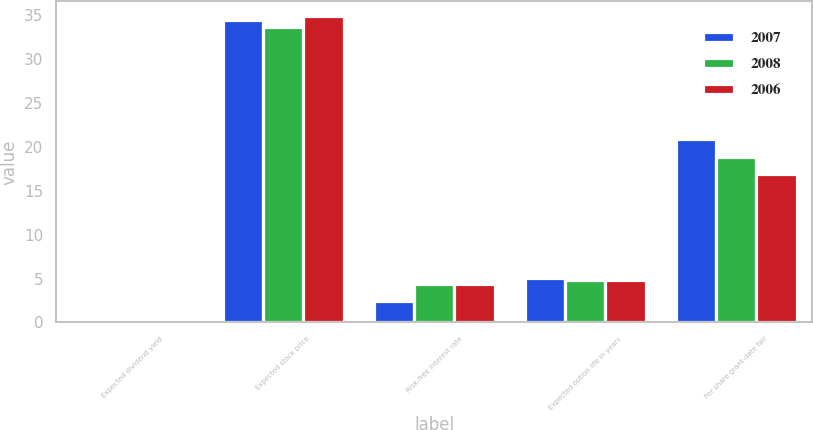Convert chart. <chart><loc_0><loc_0><loc_500><loc_500><stacked_bar_chart><ecel><fcel>Expected dividend yield<fcel>Expected stock price<fcel>Risk-free interest rate<fcel>Expected option life in years<fcel>Per share grant-date fair<nl><fcel>2007<fcel>0<fcel>34.4<fcel>2.4<fcel>5.1<fcel>20.85<nl><fcel>2008<fcel>0<fcel>33.6<fcel>4.4<fcel>4.87<fcel>18.78<nl><fcel>2006<fcel>0<fcel>34.8<fcel>4.4<fcel>4.87<fcel>16.9<nl></chart> 